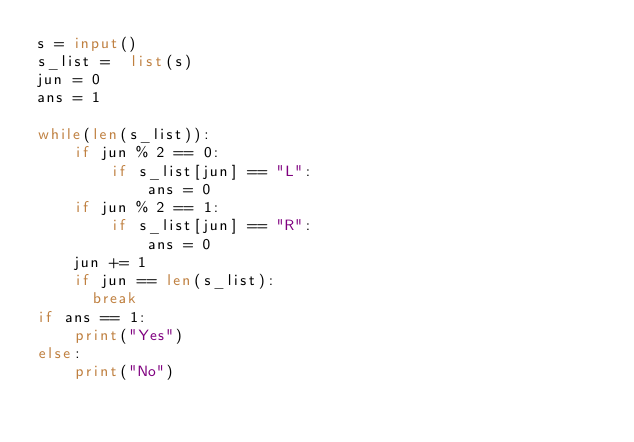<code> <loc_0><loc_0><loc_500><loc_500><_Python_>s = input()
s_list =  list(s)
jun = 0
ans = 1

while(len(s_list)):
    if jun % 2 == 0:
        if s_list[jun] == "L":
            ans = 0
    if jun % 2 == 1:
        if s_list[jun] == "R":
            ans = 0
    jun += 1
    if jun == len(s_list):
      break
if ans == 1:
    print("Yes")
else:
    print("No")</code> 